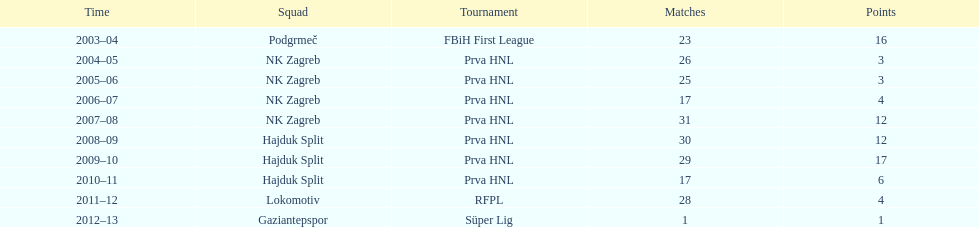The team with the most goals Hajduk Split. 